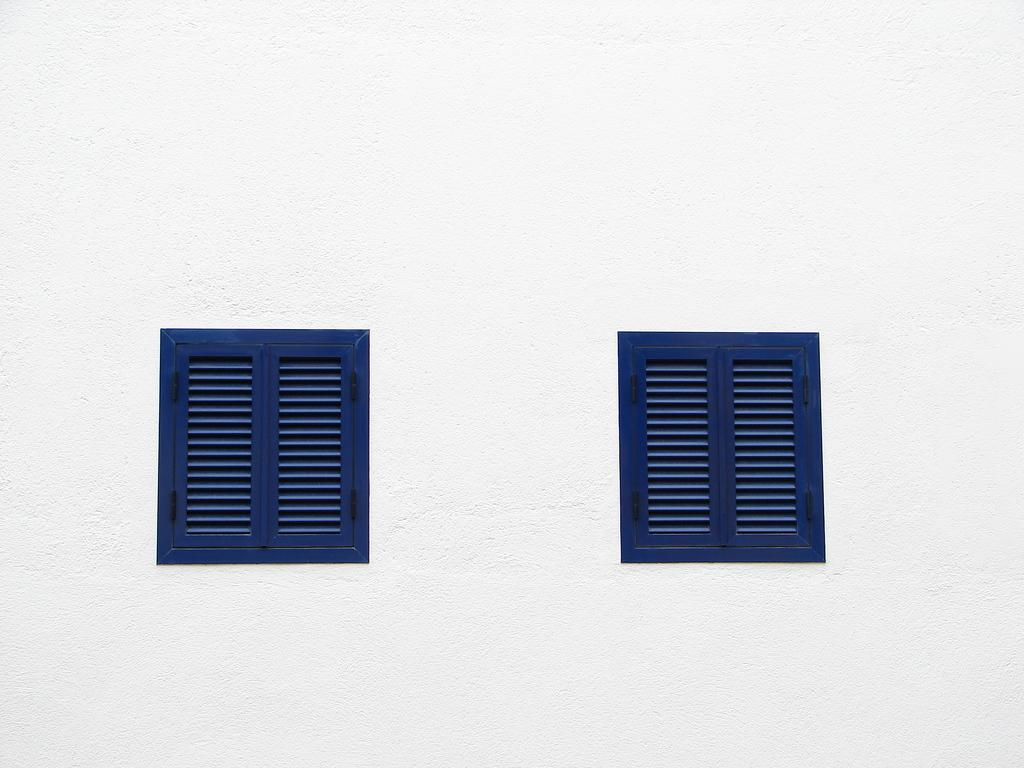How many blue windows are visible in the image? There are two blue windows in the image. What color is the wall in the image? The wall in the image is white. How many cattle are present in the image? There are no cattle present in the image; it only features two blue windows and a white wall. Can you tell me the color of the chicken in the image? There is no chicken present in the image. 